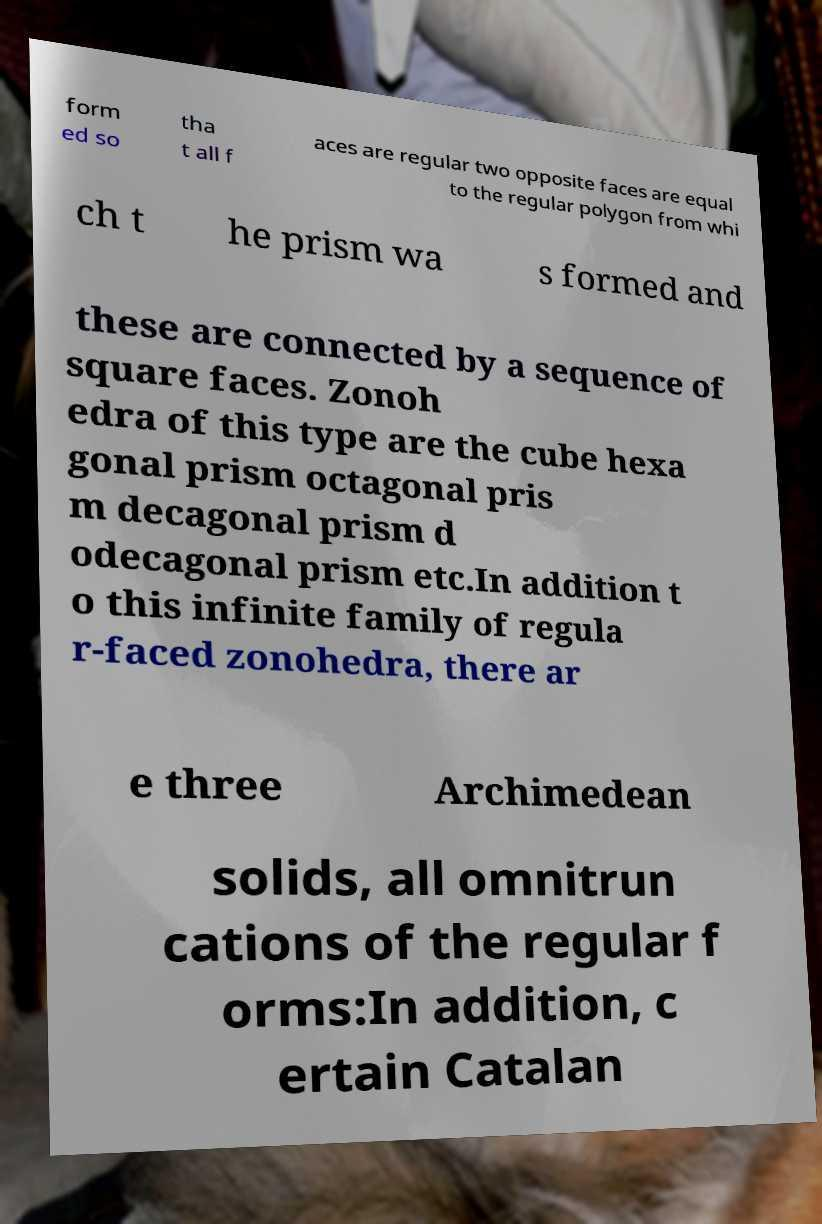Can you accurately transcribe the text from the provided image for me? form ed so tha t all f aces are regular two opposite faces are equal to the regular polygon from whi ch t he prism wa s formed and these are connected by a sequence of square faces. Zonoh edra of this type are the cube hexa gonal prism octagonal pris m decagonal prism d odecagonal prism etc.In addition t o this infinite family of regula r-faced zonohedra, there ar e three Archimedean solids, all omnitrun cations of the regular f orms:In addition, c ertain Catalan 